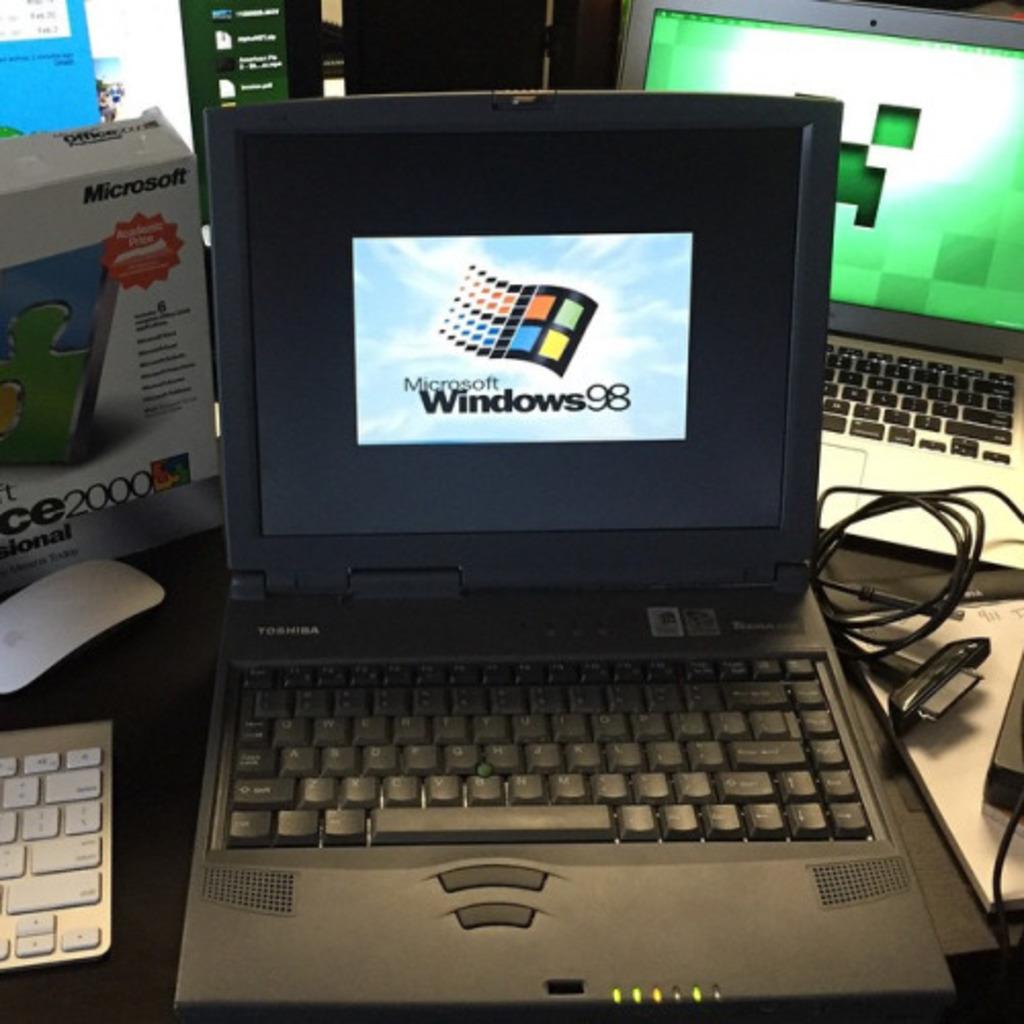What year windows is this?
Your response must be concise. 98. What operation system is on this computer?
Your answer should be compact. Windows 98. 